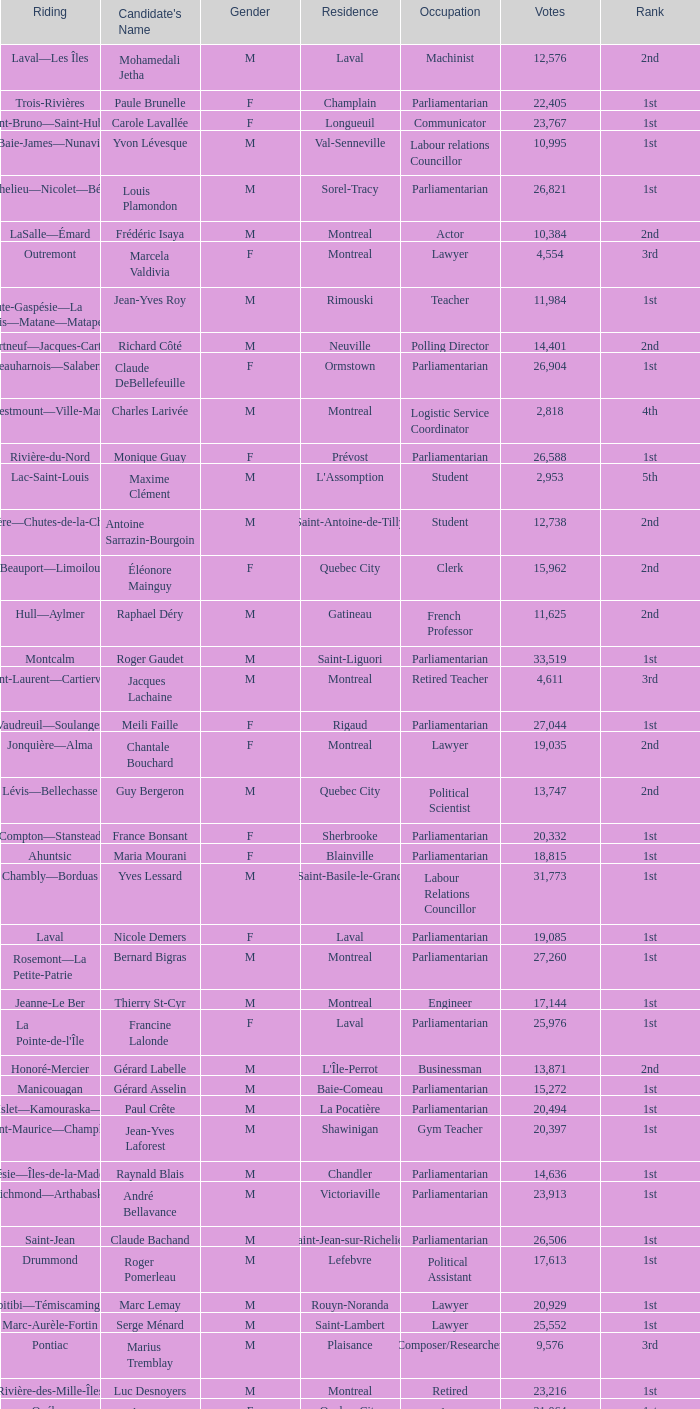What is the highest number of votes for the French Professor? 11625.0. 